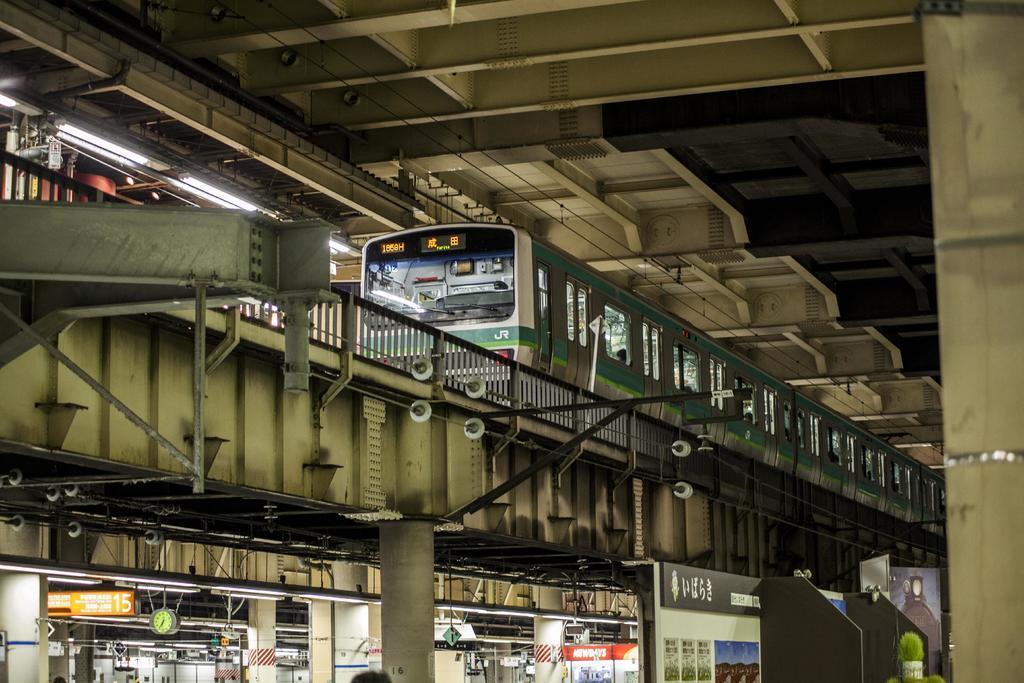How would you summarize this image in a sentence or two? In this image I can see the train to the side of the railing. I can also see the lights to the left. In the top there is a roof. In the down I can see some boards, clock and also the pillars. 